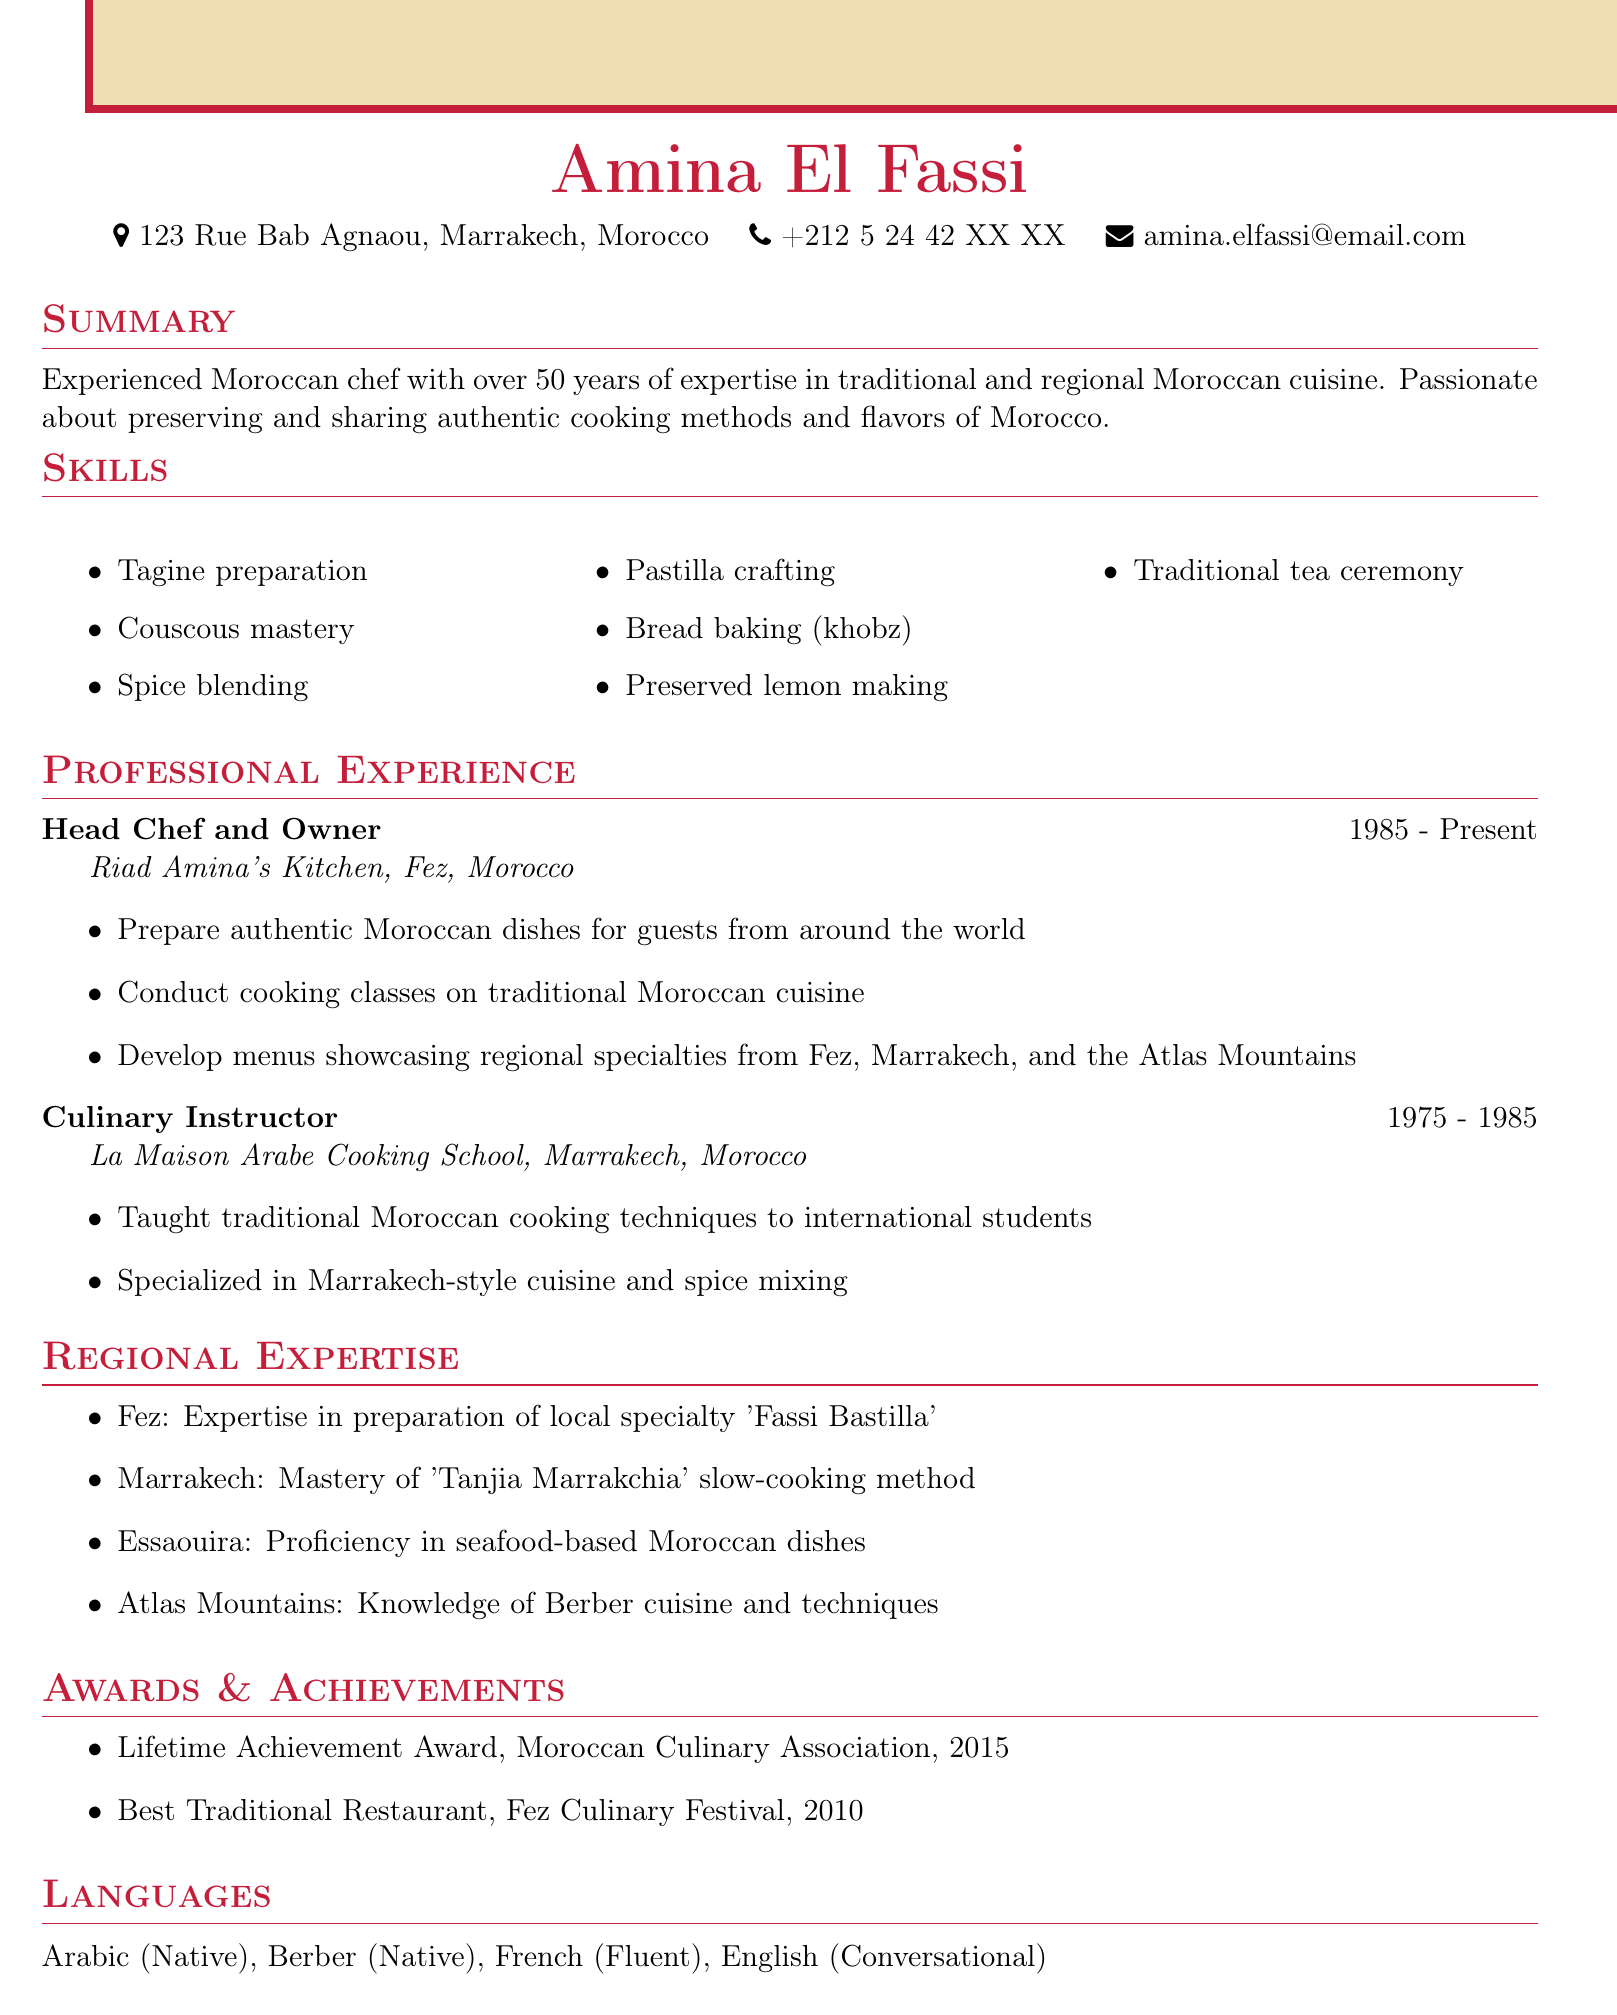What is the name of the chef? The chef is named Amina El Fassi, as stated in the document.
Answer: Amina El Fassi What is the location of Riad Amina's Kitchen? Riad Amina's Kitchen is located in Fez, Morocco, which is mentioned in the experience section.
Answer: Fez, Morocco How many years of experience does Amina have? Amina has over 50 years of expertise in traditional Moroccan cuisine, indicated in the summary.
Answer: 50 years What award did Amina receive in 2015? The document states that Amina received the Lifetime Achievement Award from the Moroccan Culinary Association in 2015.
Answer: Lifetime Achievement Award Which dish is Amina specialized in from Fez? The document highlights Amina’s expertise in preparing 'Fassi Bastilla' as a specialty from Fez.
Answer: Fassi Bastilla What language is Amina fluent in besides Arabic? According to the languages section, Amina is fluent in French.
Answer: French What is a unique skill Amina possesses? The skills section lists several unique skills; one example is Tagine preparation.
Answer: Tagine preparation In which city did Amina teach for ten years? Amina worked as a Culinary Instructor in Marrakech for ten years, as mentioned in her experience.
Answer: Marrakech What cooking method is associated with Marrakech? The document mentions that Amina has mastery of the 'Tanjia Marrakchia' slow-cooking method specific to Marrakech.
Answer: Tanjia Marrakchia 